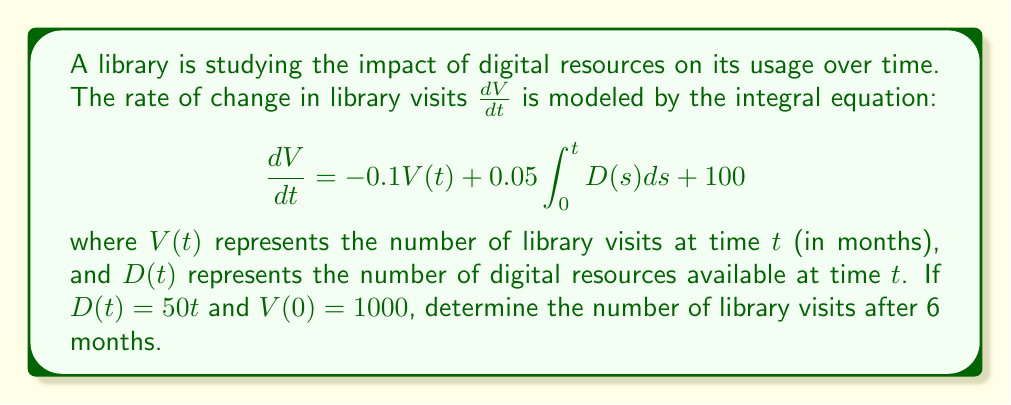What is the answer to this math problem? Let's solve this step-by-step:

1) First, we need to solve the integral inside the equation:
   $$\int_0^t D(s)ds = \int_0^t 50s\,ds = 25s^2\big|_0^t = 25t^2$$

2) Now our equation becomes:
   $$\frac{dV}{dt} = -0.1V(t) + 0.05(25t^2) + 100$$
   $$\frac{dV}{dt} = -0.1V(t) + 1.25t^2 + 100$$

3) This is a first-order linear differential equation. We can solve it using an integrating factor. The integrating factor is:
   $$\mu(t) = e^{\int 0.1 dt} = e^{0.1t}$$

4) Multiplying both sides by $\mu(t)$:
   $$e^{0.1t}\frac{dV}{dt} + 0.1e^{0.1t}V(t) = e^{0.1t}(1.25t^2 + 100)$$

5) The left side is now the derivative of $e^{0.1t}V(t)$. Integrating both sides:
   $$e^{0.1t}V(t) = \int e^{0.1t}(1.25t^2 + 100)dt$$

6) Solving the right-hand integral (using integration by parts):
   $$e^{0.1t}V(t) = e^{0.1t}(125t^2 + 2500t + 1000) + C$$

7) Dividing both sides by $e^{0.1t}$:
   $$V(t) = 125t^2 + 2500t + 1000 + Ce^{-0.1t}$$

8) Using the initial condition $V(0) = 1000$:
   $$1000 = 1000 + C$$
   $$C = 0$$

9) Therefore, our solution is:
   $$V(t) = 125t^2 + 2500t + 1000$$

10) To find the number of visits after 6 months, we substitute $t = 6$:
    $$V(6) = 125(6^2) + 2500(6) + 1000 = 4500 + 15000 + 1000 = 20500$$
Answer: 20500 visits 